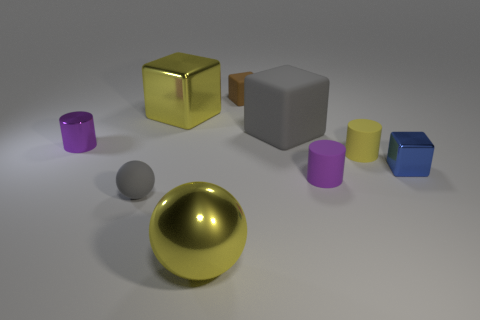How many small blue shiny blocks are behind the small yellow cylinder?
Make the answer very short. 0. What color is the metallic cylinder?
Ensure brevity in your answer.  Purple. How many small things are either gray matte blocks or yellow things?
Offer a terse response. 1. There is a tiny thing in front of the tiny purple rubber cylinder; is its color the same as the matte cube that is on the right side of the brown thing?
Your response must be concise. Yes. How many other objects are there of the same color as the large metal sphere?
Ensure brevity in your answer.  2. The large yellow object in front of the small matte ball has what shape?
Your response must be concise. Sphere. Are there fewer tiny blue metallic blocks than big purple rubber objects?
Provide a short and direct response. No. Does the tiny purple thing that is in front of the tiny blue block have the same material as the yellow ball?
Your response must be concise. No. Are there any small purple cylinders in front of the tiny purple shiny cylinder?
Ensure brevity in your answer.  Yes. What is the color of the big shiny object that is in front of the metal object behind the small purple cylinder that is on the left side of the big gray matte cube?
Keep it short and to the point. Yellow. 